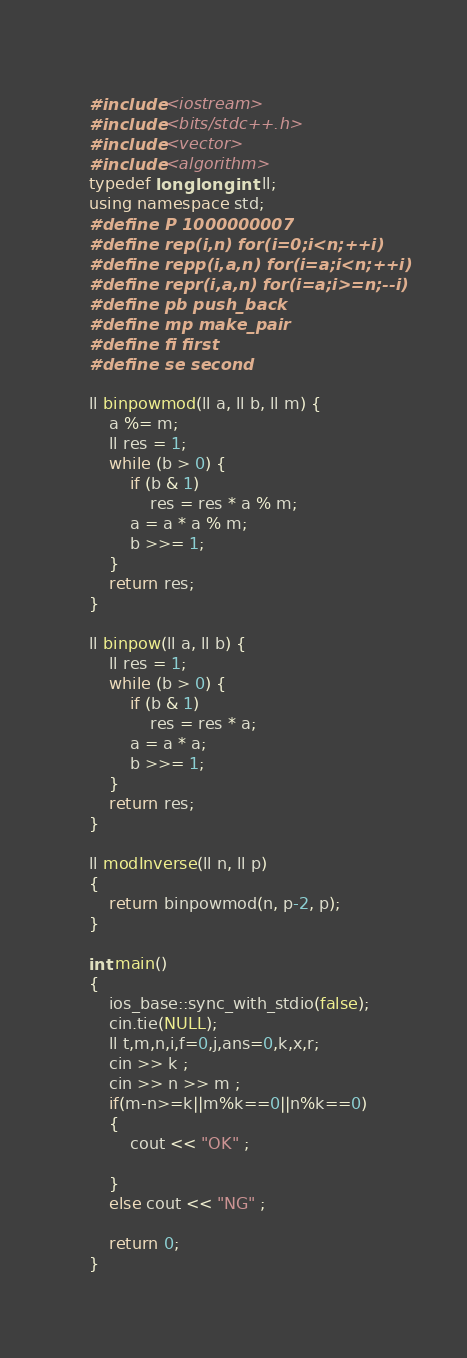<code> <loc_0><loc_0><loc_500><loc_500><_C++_>#include <iostream>
#include <bits/stdc++.h>
#include <vector>
#include <algorithm>
typedef long long int ll;
using namespace std;
#define P 1000000007
#define rep(i,n) for(i=0;i<n;++i)
#define repp(i,a,n) for(i=a;i<n;++i)
#define repr(i,a,n) for(i=a;i>=n;--i)
#define pb push_back
#define mp make_pair
#define fi first
#define se second

ll binpowmod(ll a, ll b, ll m) {
    a %= m;
    ll res = 1;
    while (b > 0) {
        if (b & 1)
            res = res * a % m;
        a = a * a % m;
        b >>= 1;
    }
    return res;
}

ll binpow(ll a, ll b) {
    ll res = 1;
    while (b > 0) {
        if (b & 1)
            res = res * a;
        a = a * a;
        b >>= 1;
    }
    return res;
}

ll modInverse(ll n, ll p)
{
    return binpowmod(n, p-2, p);
}

int main() 
{
    ios_base::sync_with_stdio(false);
    cin.tie(NULL);
    ll t,m,n,i,f=0,j,ans=0,k,x,r;
    cin >> k ;
    cin >> n >> m ;
    if(m-n>=k||m%k==0||n%k==0) 
    {
        cout << "OK" ;
        
    }
    else cout << "NG" ;
    
    return 0;
}</code> 